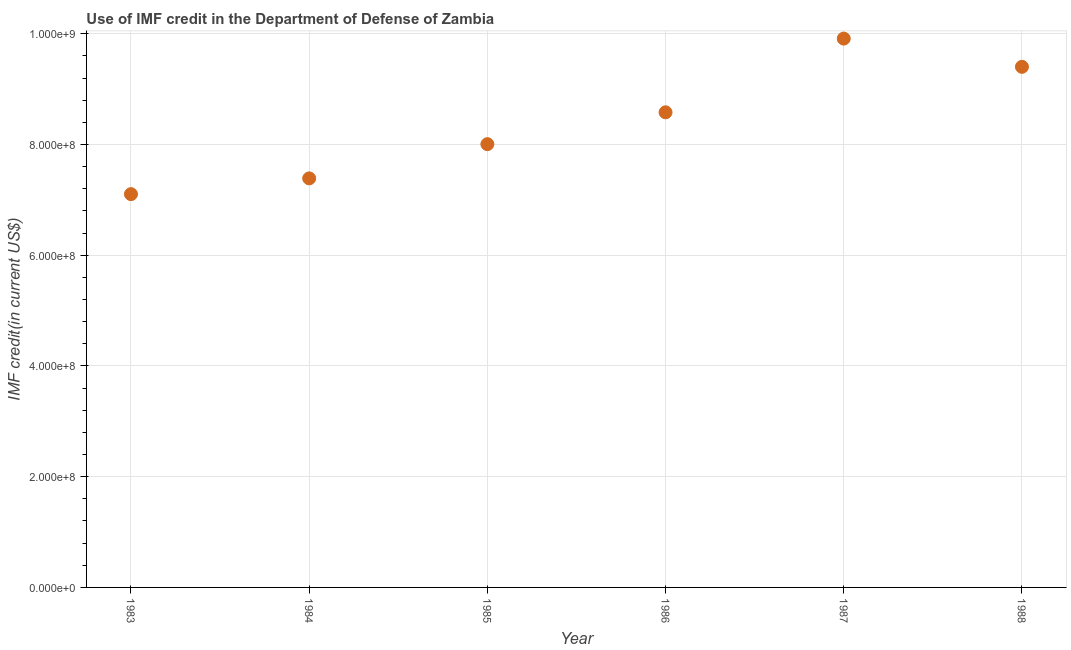What is the use of imf credit in dod in 1985?
Ensure brevity in your answer.  8.01e+08. Across all years, what is the maximum use of imf credit in dod?
Your response must be concise. 9.91e+08. Across all years, what is the minimum use of imf credit in dod?
Provide a succinct answer. 7.10e+08. What is the sum of the use of imf credit in dod?
Offer a terse response. 5.04e+09. What is the difference between the use of imf credit in dod in 1984 and 1986?
Your answer should be very brief. -1.19e+08. What is the average use of imf credit in dod per year?
Your answer should be compact. 8.40e+08. What is the median use of imf credit in dod?
Keep it short and to the point. 8.29e+08. What is the ratio of the use of imf credit in dod in 1984 to that in 1987?
Give a very brief answer. 0.75. What is the difference between the highest and the second highest use of imf credit in dod?
Give a very brief answer. 5.10e+07. What is the difference between the highest and the lowest use of imf credit in dod?
Your answer should be compact. 2.81e+08. In how many years, is the use of imf credit in dod greater than the average use of imf credit in dod taken over all years?
Offer a very short reply. 3. Does the use of imf credit in dod monotonically increase over the years?
Provide a short and direct response. No. How many dotlines are there?
Your answer should be very brief. 1. How many years are there in the graph?
Ensure brevity in your answer.  6. Are the values on the major ticks of Y-axis written in scientific E-notation?
Your answer should be very brief. Yes. Does the graph contain any zero values?
Your answer should be compact. No. Does the graph contain grids?
Give a very brief answer. Yes. What is the title of the graph?
Your answer should be compact. Use of IMF credit in the Department of Defense of Zambia. What is the label or title of the X-axis?
Give a very brief answer. Year. What is the label or title of the Y-axis?
Keep it short and to the point. IMF credit(in current US$). What is the IMF credit(in current US$) in 1983?
Your answer should be very brief. 7.10e+08. What is the IMF credit(in current US$) in 1984?
Offer a very short reply. 7.39e+08. What is the IMF credit(in current US$) in 1985?
Ensure brevity in your answer.  8.01e+08. What is the IMF credit(in current US$) in 1986?
Provide a succinct answer. 8.58e+08. What is the IMF credit(in current US$) in 1987?
Your response must be concise. 9.91e+08. What is the IMF credit(in current US$) in 1988?
Offer a terse response. 9.40e+08. What is the difference between the IMF credit(in current US$) in 1983 and 1984?
Provide a succinct answer. -2.85e+07. What is the difference between the IMF credit(in current US$) in 1983 and 1985?
Offer a terse response. -9.03e+07. What is the difference between the IMF credit(in current US$) in 1983 and 1986?
Ensure brevity in your answer.  -1.48e+08. What is the difference between the IMF credit(in current US$) in 1983 and 1987?
Provide a succinct answer. -2.81e+08. What is the difference between the IMF credit(in current US$) in 1983 and 1988?
Provide a succinct answer. -2.30e+08. What is the difference between the IMF credit(in current US$) in 1984 and 1985?
Give a very brief answer. -6.18e+07. What is the difference between the IMF credit(in current US$) in 1984 and 1986?
Your response must be concise. -1.19e+08. What is the difference between the IMF credit(in current US$) in 1984 and 1987?
Offer a very short reply. -2.52e+08. What is the difference between the IMF credit(in current US$) in 1984 and 1988?
Your answer should be very brief. -2.02e+08. What is the difference between the IMF credit(in current US$) in 1985 and 1986?
Provide a succinct answer. -5.75e+07. What is the difference between the IMF credit(in current US$) in 1985 and 1987?
Offer a very short reply. -1.91e+08. What is the difference between the IMF credit(in current US$) in 1985 and 1988?
Ensure brevity in your answer.  -1.40e+08. What is the difference between the IMF credit(in current US$) in 1986 and 1987?
Offer a very short reply. -1.33e+08. What is the difference between the IMF credit(in current US$) in 1986 and 1988?
Provide a short and direct response. -8.22e+07. What is the difference between the IMF credit(in current US$) in 1987 and 1988?
Your response must be concise. 5.10e+07. What is the ratio of the IMF credit(in current US$) in 1983 to that in 1984?
Provide a succinct answer. 0.96. What is the ratio of the IMF credit(in current US$) in 1983 to that in 1985?
Your answer should be very brief. 0.89. What is the ratio of the IMF credit(in current US$) in 1983 to that in 1986?
Provide a short and direct response. 0.83. What is the ratio of the IMF credit(in current US$) in 1983 to that in 1987?
Offer a terse response. 0.72. What is the ratio of the IMF credit(in current US$) in 1983 to that in 1988?
Your answer should be very brief. 0.76. What is the ratio of the IMF credit(in current US$) in 1984 to that in 1985?
Your answer should be compact. 0.92. What is the ratio of the IMF credit(in current US$) in 1984 to that in 1986?
Provide a succinct answer. 0.86. What is the ratio of the IMF credit(in current US$) in 1984 to that in 1987?
Make the answer very short. 0.74. What is the ratio of the IMF credit(in current US$) in 1984 to that in 1988?
Make the answer very short. 0.79. What is the ratio of the IMF credit(in current US$) in 1985 to that in 1986?
Provide a short and direct response. 0.93. What is the ratio of the IMF credit(in current US$) in 1985 to that in 1987?
Keep it short and to the point. 0.81. What is the ratio of the IMF credit(in current US$) in 1985 to that in 1988?
Make the answer very short. 0.85. What is the ratio of the IMF credit(in current US$) in 1986 to that in 1987?
Offer a very short reply. 0.87. What is the ratio of the IMF credit(in current US$) in 1987 to that in 1988?
Ensure brevity in your answer.  1.05. 